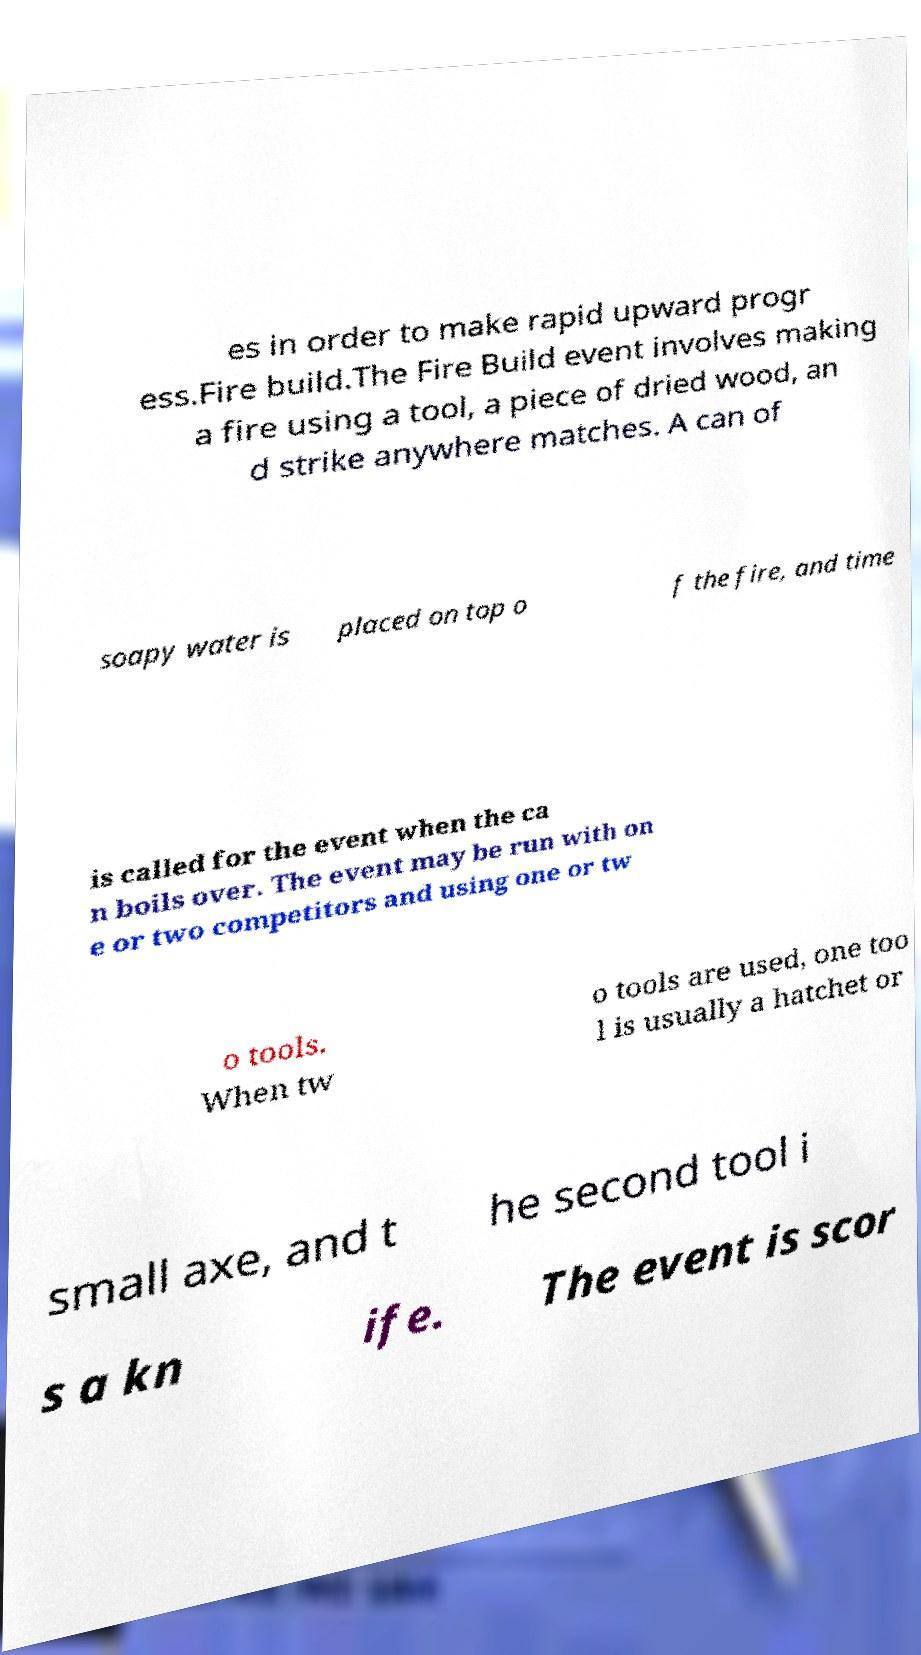Please identify and transcribe the text found in this image. es in order to make rapid upward progr ess.Fire build.The Fire Build event involves making a fire using a tool, a piece of dried wood, an d strike anywhere matches. A can of soapy water is placed on top o f the fire, and time is called for the event when the ca n boils over. The event may be run with on e or two competitors and using one or tw o tools. When tw o tools are used, one too l is usually a hatchet or small axe, and t he second tool i s a kn ife. The event is scor 